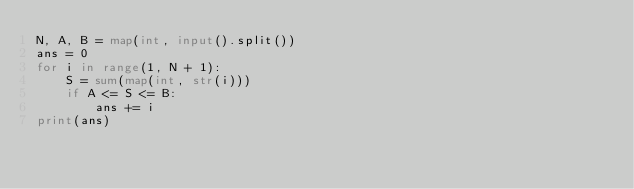Convert code to text. <code><loc_0><loc_0><loc_500><loc_500><_Python_>N, A, B = map(int, input().split())
ans = 0
for i in range(1, N + 1):
    S = sum(map(int, str(i)))
    if A <= S <= B:
        ans += i
print(ans)</code> 